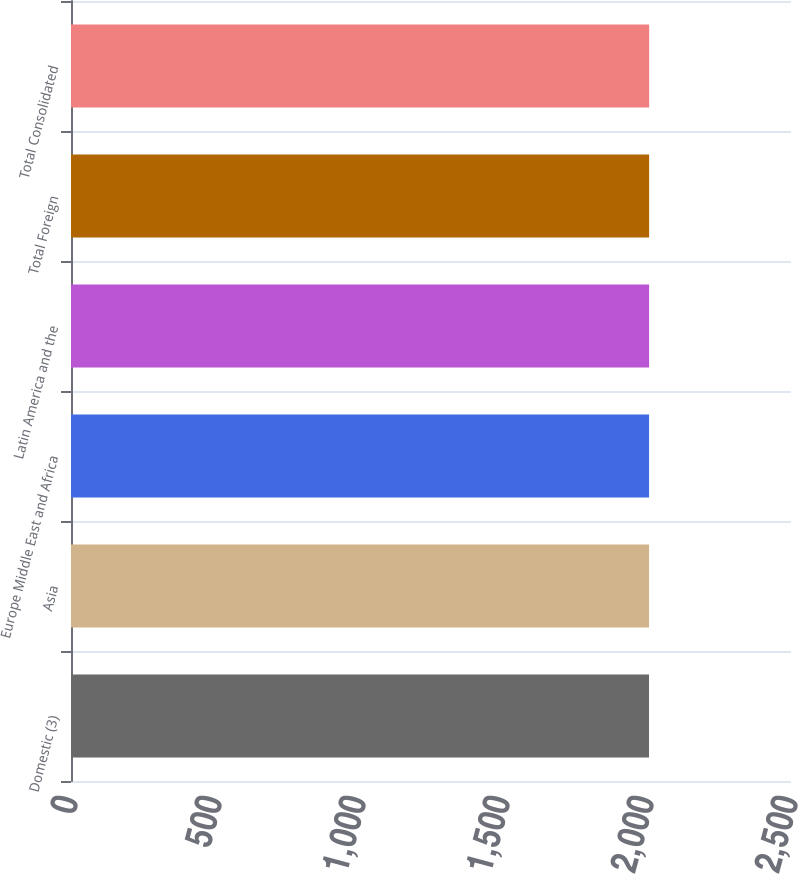<chart> <loc_0><loc_0><loc_500><loc_500><bar_chart><fcel>Domestic (3)<fcel>Asia<fcel>Europe Middle East and Africa<fcel>Latin America and the<fcel>Total Foreign<fcel>Total Consolidated<nl><fcel>2007<fcel>2007.1<fcel>2007.2<fcel>2007.3<fcel>2007.4<fcel>2007.5<nl></chart> 